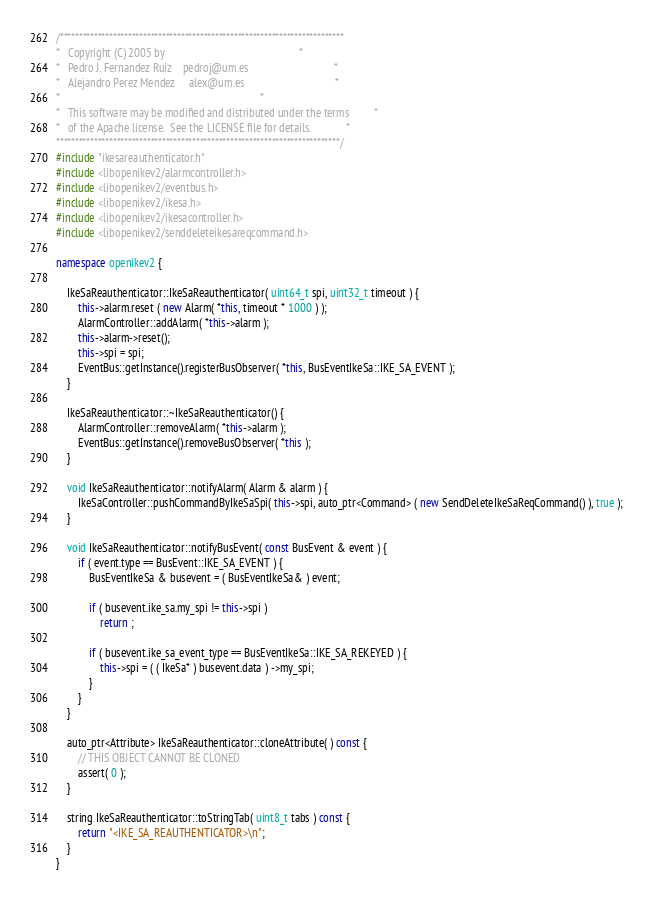Convert code to text. <code><loc_0><loc_0><loc_500><loc_500><_C++_>/***************************************************************************
*   Copyright (C) 2005 by                                                 *
*   Pedro J. Fernandez Ruiz    pedroj@um.es                               *
*   Alejandro Perez Mendez     alex@um.es                                 *
*                                                                         *
*   This software may be modified and distributed under the terms         *
*   of the Apache license.  See the LICENSE file for details.             *
***************************************************************************/
#include "ikesareauthenticator.h"
#include <libopenikev2/alarmcontroller.h>
#include <libopenikev2/eventbus.h>
#include <libopenikev2/ikesa.h>
#include <libopenikev2/ikesacontroller.h>
#include <libopenikev2/senddeleteikesareqcommand.h>

namespace openikev2 {

    IkeSaReauthenticator::IkeSaReauthenticator( uint64_t spi, uint32_t timeout ) {
        this->alarm.reset ( new Alarm( *this, timeout * 1000 ) );
        AlarmController::addAlarm( *this->alarm );
        this->alarm->reset();
        this->spi = spi;
        EventBus::getInstance().registerBusObserver( *this, BusEventIkeSa::IKE_SA_EVENT );
    }

    IkeSaReauthenticator::~IkeSaReauthenticator() {
        AlarmController::removeAlarm( *this->alarm );
        EventBus::getInstance().removeBusObserver( *this );
    }

    void IkeSaReauthenticator::notifyAlarm( Alarm & alarm ) {
        IkeSaController::pushCommandByIkeSaSpi( this->spi, auto_ptr<Command> ( new SendDeleteIkeSaReqCommand() ), true );
    }

    void IkeSaReauthenticator::notifyBusEvent( const BusEvent & event ) {
        if ( event.type == BusEvent::IKE_SA_EVENT ) {
            BusEventIkeSa & busevent = ( BusEventIkeSa& ) event;

            if ( busevent.ike_sa.my_spi != this->spi )
                return ;

            if ( busevent.ike_sa_event_type == BusEventIkeSa::IKE_SA_REKEYED ) {
                this->spi = ( ( IkeSa* ) busevent.data ) ->my_spi;
            }
        }
    }

    auto_ptr<Attribute> IkeSaReauthenticator::cloneAttribute( ) const {
        // THIS OBJECT CANNOT BE CLONED
        assert( 0 );
    }

    string IkeSaReauthenticator::toStringTab( uint8_t tabs ) const {
        return "<IKE_SA_REAUTHENTICATOR>\n";
    }
}
</code> 